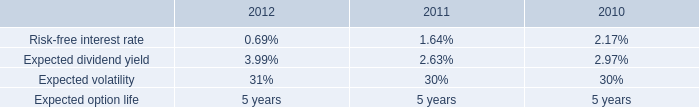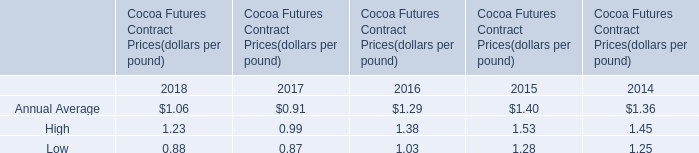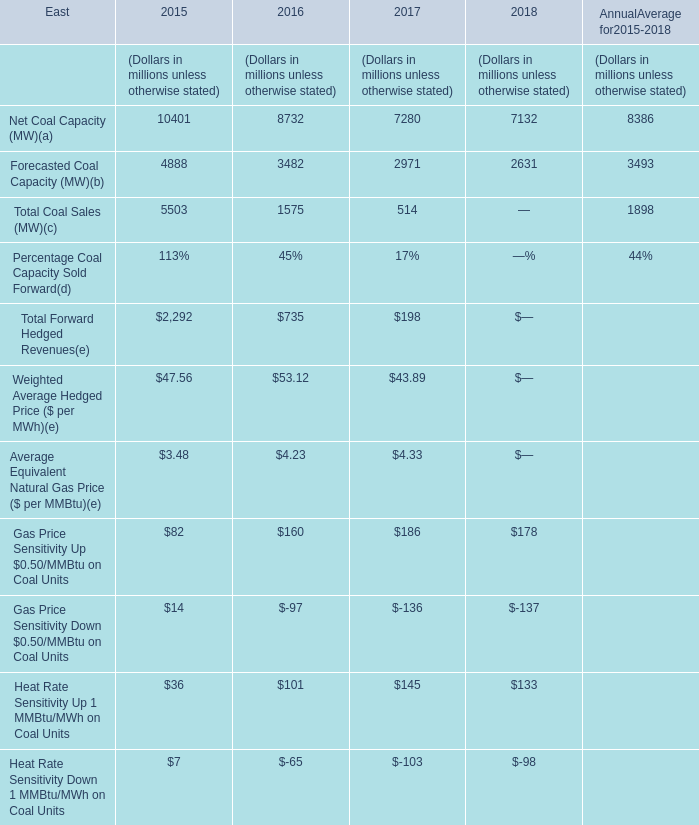Which year is Fore casted Coal Capacity the least? 
Answer: 2018. 